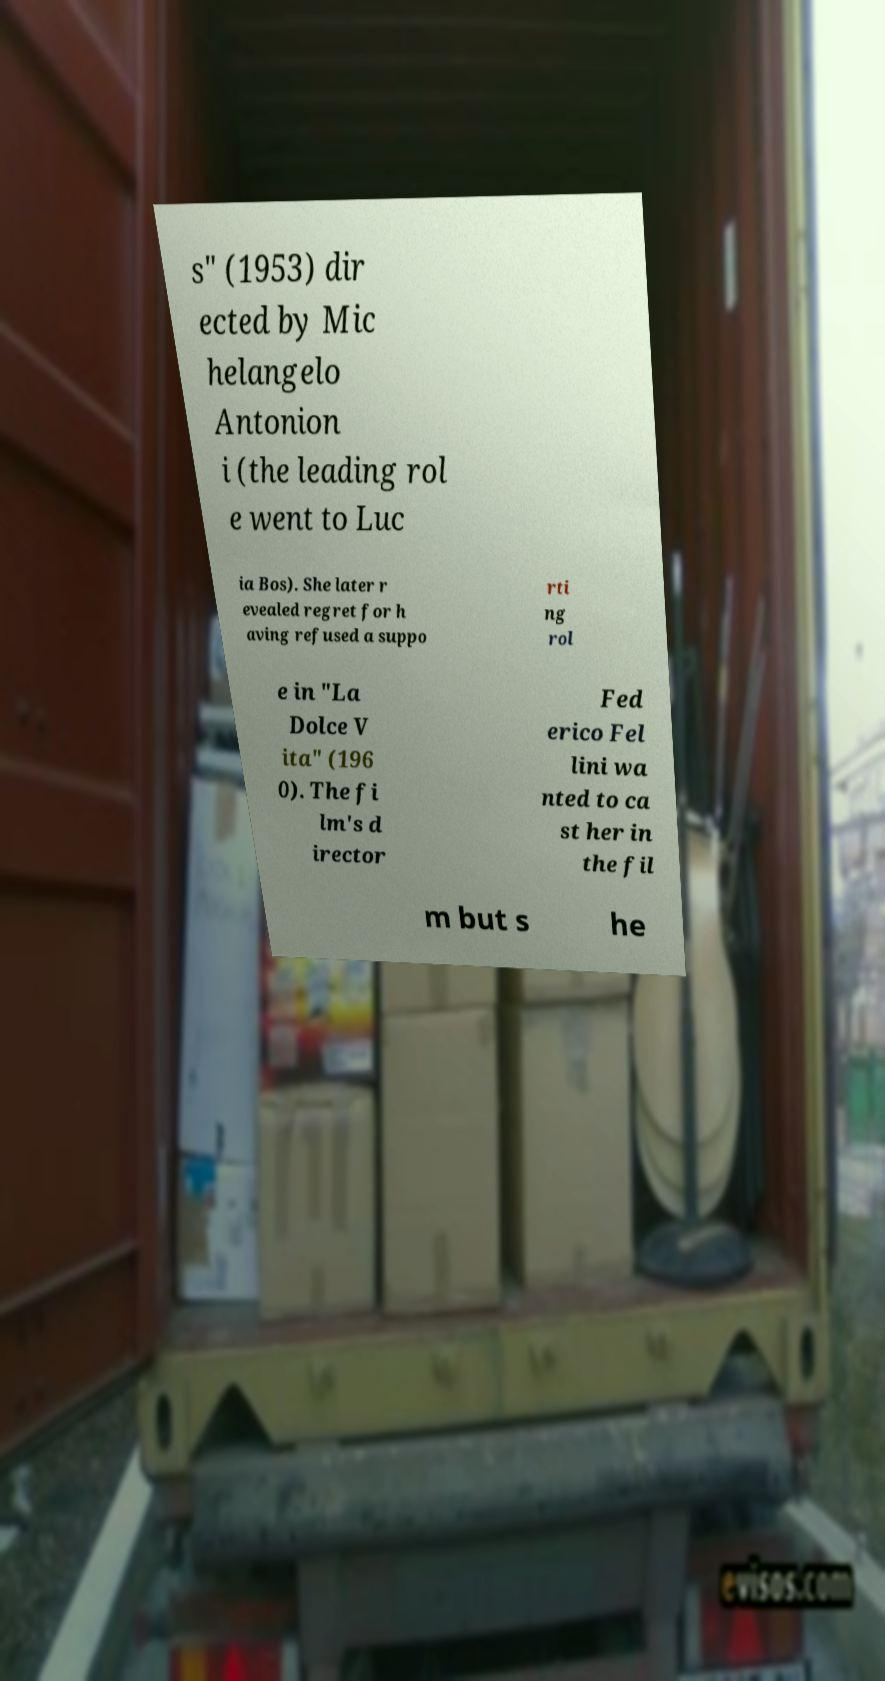Please identify and transcribe the text found in this image. s" (1953) dir ected by Mic helangelo Antonion i (the leading rol e went to Luc ia Bos). She later r evealed regret for h aving refused a suppo rti ng rol e in "La Dolce V ita" (196 0). The fi lm's d irector Fed erico Fel lini wa nted to ca st her in the fil m but s he 